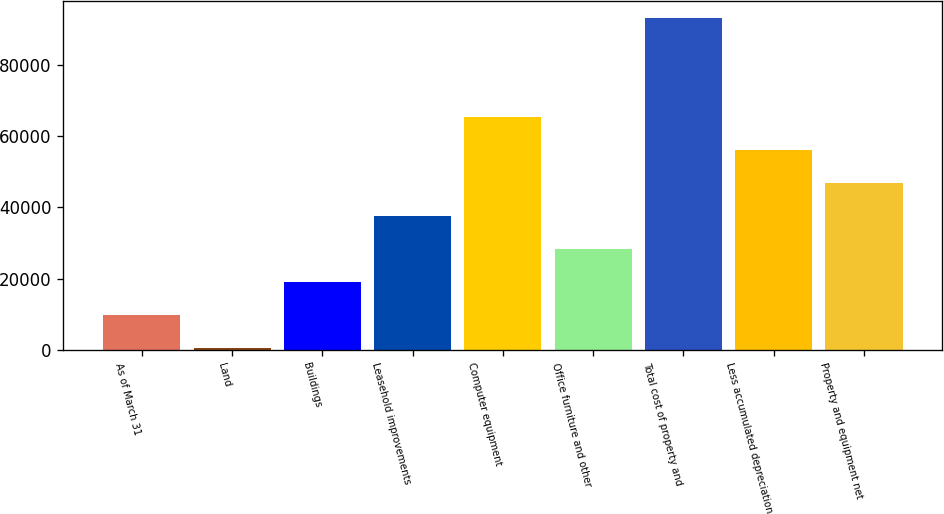Convert chart. <chart><loc_0><loc_0><loc_500><loc_500><bar_chart><fcel>As of March 31<fcel>Land<fcel>Buildings<fcel>Leasehold improvements<fcel>Computer equipment<fcel>Office furniture and other<fcel>Total cost of property and<fcel>Less accumulated depreciation<fcel>Property and equipment net<nl><fcel>9821.2<fcel>557<fcel>19085.4<fcel>37613.8<fcel>65406.4<fcel>28349.6<fcel>93199<fcel>56142.2<fcel>46878<nl></chart> 